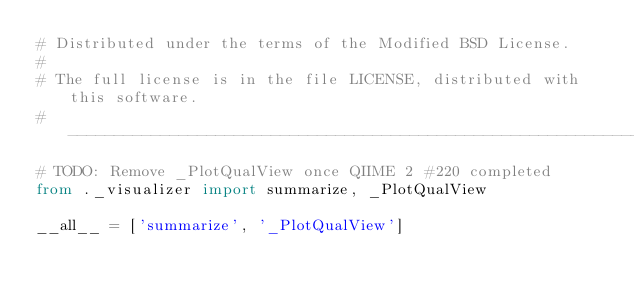<code> <loc_0><loc_0><loc_500><loc_500><_Python_># Distributed under the terms of the Modified BSD License.
#
# The full license is in the file LICENSE, distributed with this software.
# ----------------------------------------------------------------------------
# TODO: Remove _PlotQualView once QIIME 2 #220 completed
from ._visualizer import summarize, _PlotQualView

__all__ = ['summarize', '_PlotQualView']
</code> 